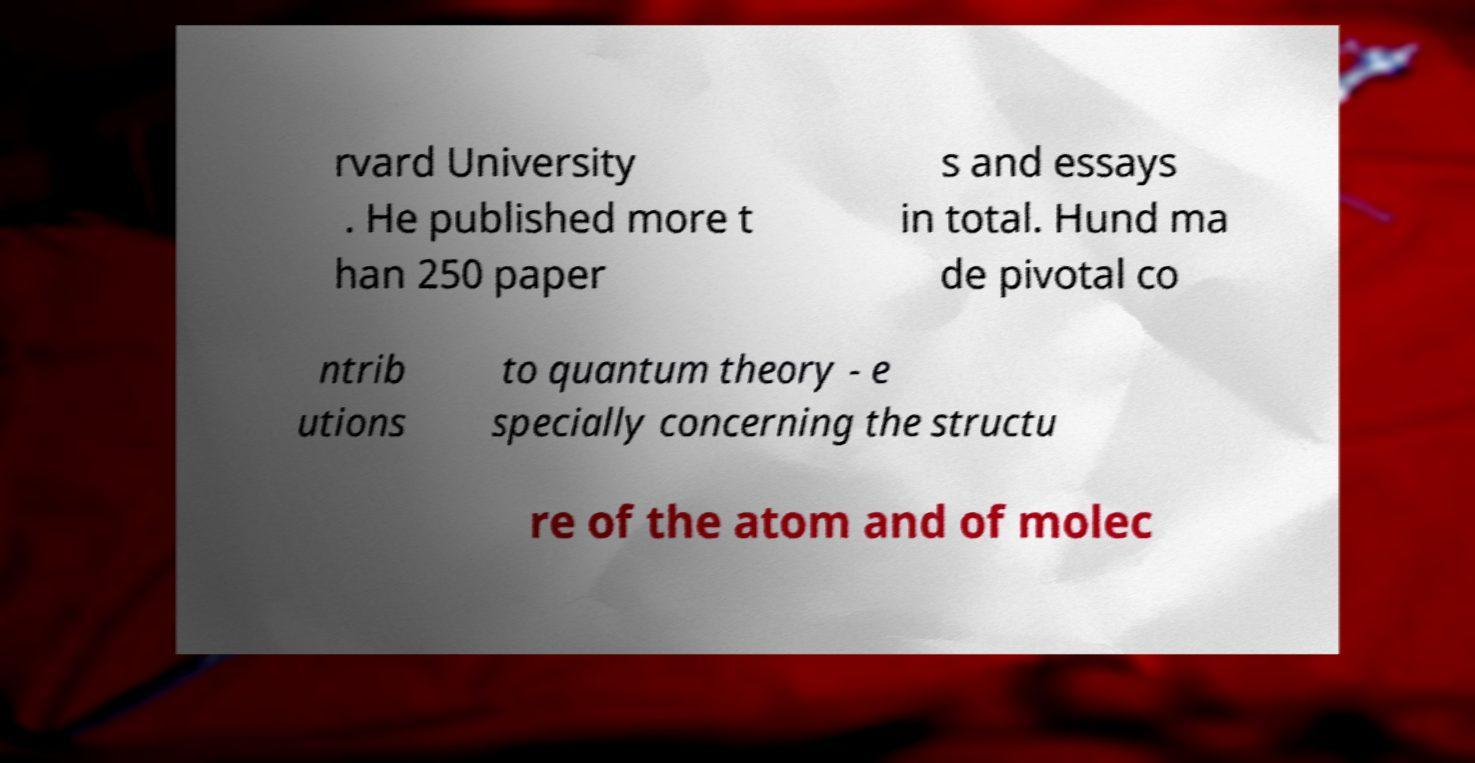Could you extract and type out the text from this image? rvard University . He published more t han 250 paper s and essays in total. Hund ma de pivotal co ntrib utions to quantum theory - e specially concerning the structu re of the atom and of molec 